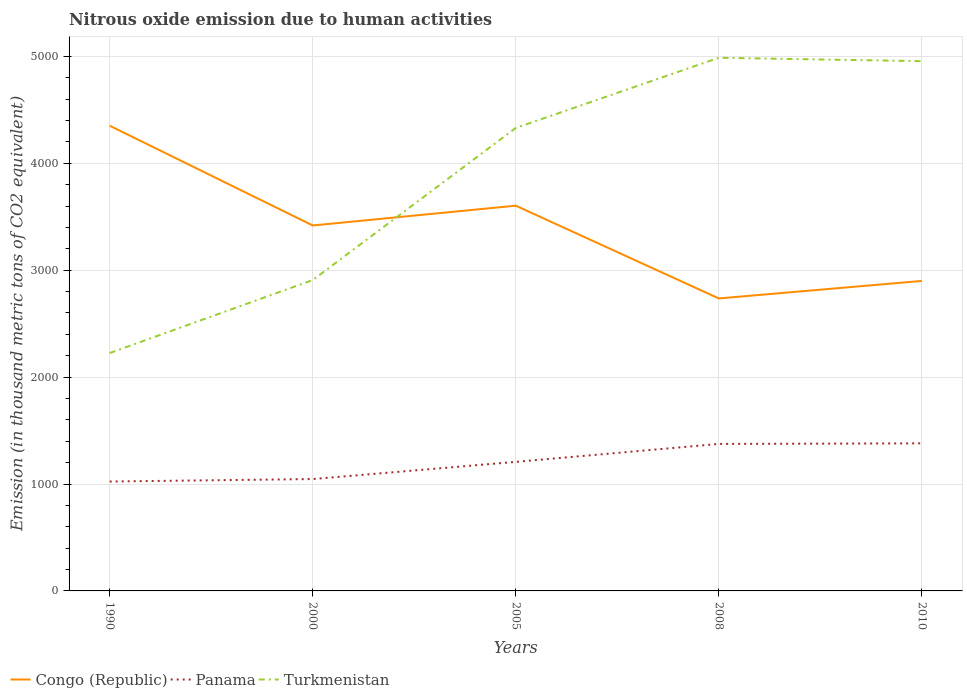How many different coloured lines are there?
Your answer should be very brief. 3. Across all years, what is the maximum amount of nitrous oxide emitted in Congo (Republic)?
Offer a terse response. 2735.8. In which year was the amount of nitrous oxide emitted in Panama maximum?
Ensure brevity in your answer.  1990. What is the total amount of nitrous oxide emitted in Panama in the graph?
Ensure brevity in your answer.  -357.1. What is the difference between the highest and the second highest amount of nitrous oxide emitted in Panama?
Give a very brief answer. 357.1. What is the difference between the highest and the lowest amount of nitrous oxide emitted in Turkmenistan?
Ensure brevity in your answer.  3. How many lines are there?
Give a very brief answer. 3. Are the values on the major ticks of Y-axis written in scientific E-notation?
Your answer should be very brief. No. Does the graph contain any zero values?
Offer a very short reply. No. How many legend labels are there?
Provide a succinct answer. 3. What is the title of the graph?
Give a very brief answer. Nitrous oxide emission due to human activities. Does "Burundi" appear as one of the legend labels in the graph?
Your answer should be compact. No. What is the label or title of the Y-axis?
Offer a very short reply. Emission (in thousand metric tons of CO2 equivalent). What is the Emission (in thousand metric tons of CO2 equivalent) of Congo (Republic) in 1990?
Offer a terse response. 4351.5. What is the Emission (in thousand metric tons of CO2 equivalent) in Panama in 1990?
Provide a succinct answer. 1023.3. What is the Emission (in thousand metric tons of CO2 equivalent) of Turkmenistan in 1990?
Keep it short and to the point. 2225.1. What is the Emission (in thousand metric tons of CO2 equivalent) in Congo (Republic) in 2000?
Make the answer very short. 3418.3. What is the Emission (in thousand metric tons of CO2 equivalent) in Panama in 2000?
Give a very brief answer. 1046.4. What is the Emission (in thousand metric tons of CO2 equivalent) in Turkmenistan in 2000?
Your answer should be compact. 2907.9. What is the Emission (in thousand metric tons of CO2 equivalent) in Congo (Republic) in 2005?
Provide a short and direct response. 3603.5. What is the Emission (in thousand metric tons of CO2 equivalent) of Panama in 2005?
Your answer should be very brief. 1207.1. What is the Emission (in thousand metric tons of CO2 equivalent) in Turkmenistan in 2005?
Your answer should be compact. 4330.6. What is the Emission (in thousand metric tons of CO2 equivalent) in Congo (Republic) in 2008?
Your answer should be compact. 2735.8. What is the Emission (in thousand metric tons of CO2 equivalent) in Panama in 2008?
Give a very brief answer. 1375. What is the Emission (in thousand metric tons of CO2 equivalent) in Turkmenistan in 2008?
Offer a terse response. 4987.1. What is the Emission (in thousand metric tons of CO2 equivalent) of Congo (Republic) in 2010?
Your answer should be very brief. 2899.8. What is the Emission (in thousand metric tons of CO2 equivalent) of Panama in 2010?
Provide a succinct answer. 1380.4. What is the Emission (in thousand metric tons of CO2 equivalent) in Turkmenistan in 2010?
Provide a succinct answer. 4955.2. Across all years, what is the maximum Emission (in thousand metric tons of CO2 equivalent) of Congo (Republic)?
Your answer should be very brief. 4351.5. Across all years, what is the maximum Emission (in thousand metric tons of CO2 equivalent) in Panama?
Give a very brief answer. 1380.4. Across all years, what is the maximum Emission (in thousand metric tons of CO2 equivalent) in Turkmenistan?
Provide a succinct answer. 4987.1. Across all years, what is the minimum Emission (in thousand metric tons of CO2 equivalent) of Congo (Republic)?
Offer a terse response. 2735.8. Across all years, what is the minimum Emission (in thousand metric tons of CO2 equivalent) in Panama?
Your answer should be very brief. 1023.3. Across all years, what is the minimum Emission (in thousand metric tons of CO2 equivalent) in Turkmenistan?
Your response must be concise. 2225.1. What is the total Emission (in thousand metric tons of CO2 equivalent) in Congo (Republic) in the graph?
Make the answer very short. 1.70e+04. What is the total Emission (in thousand metric tons of CO2 equivalent) in Panama in the graph?
Make the answer very short. 6032.2. What is the total Emission (in thousand metric tons of CO2 equivalent) in Turkmenistan in the graph?
Your answer should be very brief. 1.94e+04. What is the difference between the Emission (in thousand metric tons of CO2 equivalent) in Congo (Republic) in 1990 and that in 2000?
Offer a very short reply. 933.2. What is the difference between the Emission (in thousand metric tons of CO2 equivalent) of Panama in 1990 and that in 2000?
Your answer should be very brief. -23.1. What is the difference between the Emission (in thousand metric tons of CO2 equivalent) of Turkmenistan in 1990 and that in 2000?
Offer a terse response. -682.8. What is the difference between the Emission (in thousand metric tons of CO2 equivalent) in Congo (Republic) in 1990 and that in 2005?
Offer a very short reply. 748. What is the difference between the Emission (in thousand metric tons of CO2 equivalent) of Panama in 1990 and that in 2005?
Provide a short and direct response. -183.8. What is the difference between the Emission (in thousand metric tons of CO2 equivalent) in Turkmenistan in 1990 and that in 2005?
Your response must be concise. -2105.5. What is the difference between the Emission (in thousand metric tons of CO2 equivalent) in Congo (Republic) in 1990 and that in 2008?
Your response must be concise. 1615.7. What is the difference between the Emission (in thousand metric tons of CO2 equivalent) of Panama in 1990 and that in 2008?
Your answer should be compact. -351.7. What is the difference between the Emission (in thousand metric tons of CO2 equivalent) in Turkmenistan in 1990 and that in 2008?
Your response must be concise. -2762. What is the difference between the Emission (in thousand metric tons of CO2 equivalent) in Congo (Republic) in 1990 and that in 2010?
Make the answer very short. 1451.7. What is the difference between the Emission (in thousand metric tons of CO2 equivalent) in Panama in 1990 and that in 2010?
Give a very brief answer. -357.1. What is the difference between the Emission (in thousand metric tons of CO2 equivalent) in Turkmenistan in 1990 and that in 2010?
Your response must be concise. -2730.1. What is the difference between the Emission (in thousand metric tons of CO2 equivalent) of Congo (Republic) in 2000 and that in 2005?
Your answer should be compact. -185.2. What is the difference between the Emission (in thousand metric tons of CO2 equivalent) of Panama in 2000 and that in 2005?
Ensure brevity in your answer.  -160.7. What is the difference between the Emission (in thousand metric tons of CO2 equivalent) of Turkmenistan in 2000 and that in 2005?
Your answer should be very brief. -1422.7. What is the difference between the Emission (in thousand metric tons of CO2 equivalent) of Congo (Republic) in 2000 and that in 2008?
Your answer should be compact. 682.5. What is the difference between the Emission (in thousand metric tons of CO2 equivalent) in Panama in 2000 and that in 2008?
Make the answer very short. -328.6. What is the difference between the Emission (in thousand metric tons of CO2 equivalent) in Turkmenistan in 2000 and that in 2008?
Give a very brief answer. -2079.2. What is the difference between the Emission (in thousand metric tons of CO2 equivalent) of Congo (Republic) in 2000 and that in 2010?
Provide a succinct answer. 518.5. What is the difference between the Emission (in thousand metric tons of CO2 equivalent) in Panama in 2000 and that in 2010?
Offer a very short reply. -334. What is the difference between the Emission (in thousand metric tons of CO2 equivalent) of Turkmenistan in 2000 and that in 2010?
Provide a short and direct response. -2047.3. What is the difference between the Emission (in thousand metric tons of CO2 equivalent) of Congo (Republic) in 2005 and that in 2008?
Make the answer very short. 867.7. What is the difference between the Emission (in thousand metric tons of CO2 equivalent) of Panama in 2005 and that in 2008?
Offer a very short reply. -167.9. What is the difference between the Emission (in thousand metric tons of CO2 equivalent) in Turkmenistan in 2005 and that in 2008?
Offer a terse response. -656.5. What is the difference between the Emission (in thousand metric tons of CO2 equivalent) of Congo (Republic) in 2005 and that in 2010?
Give a very brief answer. 703.7. What is the difference between the Emission (in thousand metric tons of CO2 equivalent) in Panama in 2005 and that in 2010?
Keep it short and to the point. -173.3. What is the difference between the Emission (in thousand metric tons of CO2 equivalent) of Turkmenistan in 2005 and that in 2010?
Ensure brevity in your answer.  -624.6. What is the difference between the Emission (in thousand metric tons of CO2 equivalent) of Congo (Republic) in 2008 and that in 2010?
Your answer should be compact. -164. What is the difference between the Emission (in thousand metric tons of CO2 equivalent) of Turkmenistan in 2008 and that in 2010?
Provide a short and direct response. 31.9. What is the difference between the Emission (in thousand metric tons of CO2 equivalent) in Congo (Republic) in 1990 and the Emission (in thousand metric tons of CO2 equivalent) in Panama in 2000?
Your answer should be very brief. 3305.1. What is the difference between the Emission (in thousand metric tons of CO2 equivalent) in Congo (Republic) in 1990 and the Emission (in thousand metric tons of CO2 equivalent) in Turkmenistan in 2000?
Provide a short and direct response. 1443.6. What is the difference between the Emission (in thousand metric tons of CO2 equivalent) of Panama in 1990 and the Emission (in thousand metric tons of CO2 equivalent) of Turkmenistan in 2000?
Ensure brevity in your answer.  -1884.6. What is the difference between the Emission (in thousand metric tons of CO2 equivalent) of Congo (Republic) in 1990 and the Emission (in thousand metric tons of CO2 equivalent) of Panama in 2005?
Provide a short and direct response. 3144.4. What is the difference between the Emission (in thousand metric tons of CO2 equivalent) in Congo (Republic) in 1990 and the Emission (in thousand metric tons of CO2 equivalent) in Turkmenistan in 2005?
Your answer should be compact. 20.9. What is the difference between the Emission (in thousand metric tons of CO2 equivalent) in Panama in 1990 and the Emission (in thousand metric tons of CO2 equivalent) in Turkmenistan in 2005?
Make the answer very short. -3307.3. What is the difference between the Emission (in thousand metric tons of CO2 equivalent) of Congo (Republic) in 1990 and the Emission (in thousand metric tons of CO2 equivalent) of Panama in 2008?
Your answer should be very brief. 2976.5. What is the difference between the Emission (in thousand metric tons of CO2 equivalent) of Congo (Republic) in 1990 and the Emission (in thousand metric tons of CO2 equivalent) of Turkmenistan in 2008?
Make the answer very short. -635.6. What is the difference between the Emission (in thousand metric tons of CO2 equivalent) in Panama in 1990 and the Emission (in thousand metric tons of CO2 equivalent) in Turkmenistan in 2008?
Keep it short and to the point. -3963.8. What is the difference between the Emission (in thousand metric tons of CO2 equivalent) in Congo (Republic) in 1990 and the Emission (in thousand metric tons of CO2 equivalent) in Panama in 2010?
Keep it short and to the point. 2971.1. What is the difference between the Emission (in thousand metric tons of CO2 equivalent) of Congo (Republic) in 1990 and the Emission (in thousand metric tons of CO2 equivalent) of Turkmenistan in 2010?
Offer a terse response. -603.7. What is the difference between the Emission (in thousand metric tons of CO2 equivalent) in Panama in 1990 and the Emission (in thousand metric tons of CO2 equivalent) in Turkmenistan in 2010?
Offer a terse response. -3931.9. What is the difference between the Emission (in thousand metric tons of CO2 equivalent) of Congo (Republic) in 2000 and the Emission (in thousand metric tons of CO2 equivalent) of Panama in 2005?
Your answer should be very brief. 2211.2. What is the difference between the Emission (in thousand metric tons of CO2 equivalent) in Congo (Republic) in 2000 and the Emission (in thousand metric tons of CO2 equivalent) in Turkmenistan in 2005?
Your answer should be compact. -912.3. What is the difference between the Emission (in thousand metric tons of CO2 equivalent) in Panama in 2000 and the Emission (in thousand metric tons of CO2 equivalent) in Turkmenistan in 2005?
Offer a very short reply. -3284.2. What is the difference between the Emission (in thousand metric tons of CO2 equivalent) of Congo (Republic) in 2000 and the Emission (in thousand metric tons of CO2 equivalent) of Panama in 2008?
Your response must be concise. 2043.3. What is the difference between the Emission (in thousand metric tons of CO2 equivalent) in Congo (Republic) in 2000 and the Emission (in thousand metric tons of CO2 equivalent) in Turkmenistan in 2008?
Make the answer very short. -1568.8. What is the difference between the Emission (in thousand metric tons of CO2 equivalent) in Panama in 2000 and the Emission (in thousand metric tons of CO2 equivalent) in Turkmenistan in 2008?
Provide a succinct answer. -3940.7. What is the difference between the Emission (in thousand metric tons of CO2 equivalent) of Congo (Republic) in 2000 and the Emission (in thousand metric tons of CO2 equivalent) of Panama in 2010?
Give a very brief answer. 2037.9. What is the difference between the Emission (in thousand metric tons of CO2 equivalent) in Congo (Republic) in 2000 and the Emission (in thousand metric tons of CO2 equivalent) in Turkmenistan in 2010?
Offer a very short reply. -1536.9. What is the difference between the Emission (in thousand metric tons of CO2 equivalent) of Panama in 2000 and the Emission (in thousand metric tons of CO2 equivalent) of Turkmenistan in 2010?
Provide a short and direct response. -3908.8. What is the difference between the Emission (in thousand metric tons of CO2 equivalent) of Congo (Republic) in 2005 and the Emission (in thousand metric tons of CO2 equivalent) of Panama in 2008?
Keep it short and to the point. 2228.5. What is the difference between the Emission (in thousand metric tons of CO2 equivalent) of Congo (Republic) in 2005 and the Emission (in thousand metric tons of CO2 equivalent) of Turkmenistan in 2008?
Your answer should be compact. -1383.6. What is the difference between the Emission (in thousand metric tons of CO2 equivalent) of Panama in 2005 and the Emission (in thousand metric tons of CO2 equivalent) of Turkmenistan in 2008?
Provide a short and direct response. -3780. What is the difference between the Emission (in thousand metric tons of CO2 equivalent) in Congo (Republic) in 2005 and the Emission (in thousand metric tons of CO2 equivalent) in Panama in 2010?
Provide a succinct answer. 2223.1. What is the difference between the Emission (in thousand metric tons of CO2 equivalent) in Congo (Republic) in 2005 and the Emission (in thousand metric tons of CO2 equivalent) in Turkmenistan in 2010?
Provide a succinct answer. -1351.7. What is the difference between the Emission (in thousand metric tons of CO2 equivalent) in Panama in 2005 and the Emission (in thousand metric tons of CO2 equivalent) in Turkmenistan in 2010?
Offer a terse response. -3748.1. What is the difference between the Emission (in thousand metric tons of CO2 equivalent) of Congo (Republic) in 2008 and the Emission (in thousand metric tons of CO2 equivalent) of Panama in 2010?
Keep it short and to the point. 1355.4. What is the difference between the Emission (in thousand metric tons of CO2 equivalent) of Congo (Republic) in 2008 and the Emission (in thousand metric tons of CO2 equivalent) of Turkmenistan in 2010?
Provide a short and direct response. -2219.4. What is the difference between the Emission (in thousand metric tons of CO2 equivalent) in Panama in 2008 and the Emission (in thousand metric tons of CO2 equivalent) in Turkmenistan in 2010?
Offer a very short reply. -3580.2. What is the average Emission (in thousand metric tons of CO2 equivalent) of Congo (Republic) per year?
Provide a short and direct response. 3401.78. What is the average Emission (in thousand metric tons of CO2 equivalent) of Panama per year?
Your answer should be compact. 1206.44. What is the average Emission (in thousand metric tons of CO2 equivalent) of Turkmenistan per year?
Make the answer very short. 3881.18. In the year 1990, what is the difference between the Emission (in thousand metric tons of CO2 equivalent) in Congo (Republic) and Emission (in thousand metric tons of CO2 equivalent) in Panama?
Keep it short and to the point. 3328.2. In the year 1990, what is the difference between the Emission (in thousand metric tons of CO2 equivalent) of Congo (Republic) and Emission (in thousand metric tons of CO2 equivalent) of Turkmenistan?
Make the answer very short. 2126.4. In the year 1990, what is the difference between the Emission (in thousand metric tons of CO2 equivalent) in Panama and Emission (in thousand metric tons of CO2 equivalent) in Turkmenistan?
Keep it short and to the point. -1201.8. In the year 2000, what is the difference between the Emission (in thousand metric tons of CO2 equivalent) in Congo (Republic) and Emission (in thousand metric tons of CO2 equivalent) in Panama?
Make the answer very short. 2371.9. In the year 2000, what is the difference between the Emission (in thousand metric tons of CO2 equivalent) in Congo (Republic) and Emission (in thousand metric tons of CO2 equivalent) in Turkmenistan?
Offer a terse response. 510.4. In the year 2000, what is the difference between the Emission (in thousand metric tons of CO2 equivalent) of Panama and Emission (in thousand metric tons of CO2 equivalent) of Turkmenistan?
Keep it short and to the point. -1861.5. In the year 2005, what is the difference between the Emission (in thousand metric tons of CO2 equivalent) in Congo (Republic) and Emission (in thousand metric tons of CO2 equivalent) in Panama?
Provide a short and direct response. 2396.4. In the year 2005, what is the difference between the Emission (in thousand metric tons of CO2 equivalent) in Congo (Republic) and Emission (in thousand metric tons of CO2 equivalent) in Turkmenistan?
Offer a terse response. -727.1. In the year 2005, what is the difference between the Emission (in thousand metric tons of CO2 equivalent) in Panama and Emission (in thousand metric tons of CO2 equivalent) in Turkmenistan?
Offer a terse response. -3123.5. In the year 2008, what is the difference between the Emission (in thousand metric tons of CO2 equivalent) in Congo (Republic) and Emission (in thousand metric tons of CO2 equivalent) in Panama?
Your response must be concise. 1360.8. In the year 2008, what is the difference between the Emission (in thousand metric tons of CO2 equivalent) in Congo (Republic) and Emission (in thousand metric tons of CO2 equivalent) in Turkmenistan?
Give a very brief answer. -2251.3. In the year 2008, what is the difference between the Emission (in thousand metric tons of CO2 equivalent) of Panama and Emission (in thousand metric tons of CO2 equivalent) of Turkmenistan?
Offer a very short reply. -3612.1. In the year 2010, what is the difference between the Emission (in thousand metric tons of CO2 equivalent) of Congo (Republic) and Emission (in thousand metric tons of CO2 equivalent) of Panama?
Keep it short and to the point. 1519.4. In the year 2010, what is the difference between the Emission (in thousand metric tons of CO2 equivalent) in Congo (Republic) and Emission (in thousand metric tons of CO2 equivalent) in Turkmenistan?
Ensure brevity in your answer.  -2055.4. In the year 2010, what is the difference between the Emission (in thousand metric tons of CO2 equivalent) of Panama and Emission (in thousand metric tons of CO2 equivalent) of Turkmenistan?
Your response must be concise. -3574.8. What is the ratio of the Emission (in thousand metric tons of CO2 equivalent) of Congo (Republic) in 1990 to that in 2000?
Your answer should be very brief. 1.27. What is the ratio of the Emission (in thousand metric tons of CO2 equivalent) of Panama in 1990 to that in 2000?
Offer a very short reply. 0.98. What is the ratio of the Emission (in thousand metric tons of CO2 equivalent) in Turkmenistan in 1990 to that in 2000?
Give a very brief answer. 0.77. What is the ratio of the Emission (in thousand metric tons of CO2 equivalent) in Congo (Republic) in 1990 to that in 2005?
Provide a short and direct response. 1.21. What is the ratio of the Emission (in thousand metric tons of CO2 equivalent) of Panama in 1990 to that in 2005?
Your response must be concise. 0.85. What is the ratio of the Emission (in thousand metric tons of CO2 equivalent) in Turkmenistan in 1990 to that in 2005?
Ensure brevity in your answer.  0.51. What is the ratio of the Emission (in thousand metric tons of CO2 equivalent) in Congo (Republic) in 1990 to that in 2008?
Your response must be concise. 1.59. What is the ratio of the Emission (in thousand metric tons of CO2 equivalent) in Panama in 1990 to that in 2008?
Keep it short and to the point. 0.74. What is the ratio of the Emission (in thousand metric tons of CO2 equivalent) of Turkmenistan in 1990 to that in 2008?
Your answer should be compact. 0.45. What is the ratio of the Emission (in thousand metric tons of CO2 equivalent) in Congo (Republic) in 1990 to that in 2010?
Offer a terse response. 1.5. What is the ratio of the Emission (in thousand metric tons of CO2 equivalent) of Panama in 1990 to that in 2010?
Provide a short and direct response. 0.74. What is the ratio of the Emission (in thousand metric tons of CO2 equivalent) of Turkmenistan in 1990 to that in 2010?
Provide a succinct answer. 0.45. What is the ratio of the Emission (in thousand metric tons of CO2 equivalent) of Congo (Republic) in 2000 to that in 2005?
Keep it short and to the point. 0.95. What is the ratio of the Emission (in thousand metric tons of CO2 equivalent) of Panama in 2000 to that in 2005?
Your answer should be very brief. 0.87. What is the ratio of the Emission (in thousand metric tons of CO2 equivalent) of Turkmenistan in 2000 to that in 2005?
Offer a terse response. 0.67. What is the ratio of the Emission (in thousand metric tons of CO2 equivalent) of Congo (Republic) in 2000 to that in 2008?
Your response must be concise. 1.25. What is the ratio of the Emission (in thousand metric tons of CO2 equivalent) of Panama in 2000 to that in 2008?
Make the answer very short. 0.76. What is the ratio of the Emission (in thousand metric tons of CO2 equivalent) in Turkmenistan in 2000 to that in 2008?
Your answer should be very brief. 0.58. What is the ratio of the Emission (in thousand metric tons of CO2 equivalent) in Congo (Republic) in 2000 to that in 2010?
Provide a succinct answer. 1.18. What is the ratio of the Emission (in thousand metric tons of CO2 equivalent) of Panama in 2000 to that in 2010?
Your answer should be very brief. 0.76. What is the ratio of the Emission (in thousand metric tons of CO2 equivalent) of Turkmenistan in 2000 to that in 2010?
Your answer should be compact. 0.59. What is the ratio of the Emission (in thousand metric tons of CO2 equivalent) in Congo (Republic) in 2005 to that in 2008?
Provide a short and direct response. 1.32. What is the ratio of the Emission (in thousand metric tons of CO2 equivalent) in Panama in 2005 to that in 2008?
Your answer should be very brief. 0.88. What is the ratio of the Emission (in thousand metric tons of CO2 equivalent) in Turkmenistan in 2005 to that in 2008?
Keep it short and to the point. 0.87. What is the ratio of the Emission (in thousand metric tons of CO2 equivalent) of Congo (Republic) in 2005 to that in 2010?
Keep it short and to the point. 1.24. What is the ratio of the Emission (in thousand metric tons of CO2 equivalent) of Panama in 2005 to that in 2010?
Your answer should be compact. 0.87. What is the ratio of the Emission (in thousand metric tons of CO2 equivalent) in Turkmenistan in 2005 to that in 2010?
Ensure brevity in your answer.  0.87. What is the ratio of the Emission (in thousand metric tons of CO2 equivalent) in Congo (Republic) in 2008 to that in 2010?
Give a very brief answer. 0.94. What is the ratio of the Emission (in thousand metric tons of CO2 equivalent) in Turkmenistan in 2008 to that in 2010?
Your response must be concise. 1.01. What is the difference between the highest and the second highest Emission (in thousand metric tons of CO2 equivalent) in Congo (Republic)?
Provide a short and direct response. 748. What is the difference between the highest and the second highest Emission (in thousand metric tons of CO2 equivalent) in Turkmenistan?
Offer a very short reply. 31.9. What is the difference between the highest and the lowest Emission (in thousand metric tons of CO2 equivalent) in Congo (Republic)?
Make the answer very short. 1615.7. What is the difference between the highest and the lowest Emission (in thousand metric tons of CO2 equivalent) in Panama?
Give a very brief answer. 357.1. What is the difference between the highest and the lowest Emission (in thousand metric tons of CO2 equivalent) in Turkmenistan?
Offer a very short reply. 2762. 